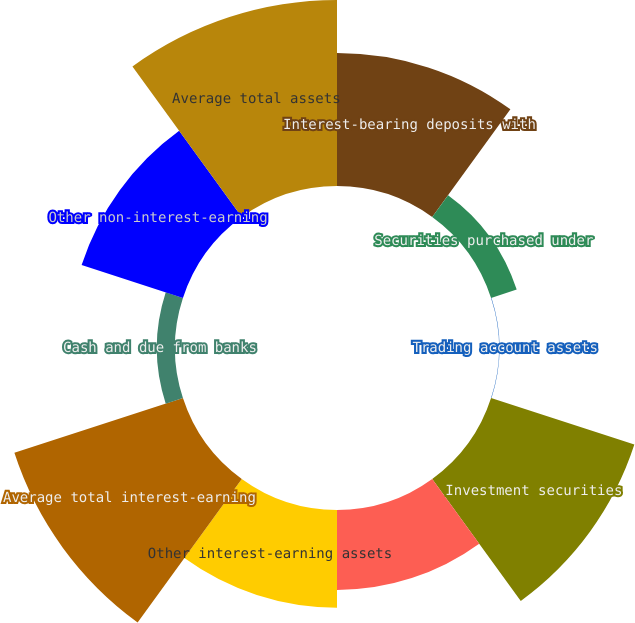Convert chart. <chart><loc_0><loc_0><loc_500><loc_500><pie_chart><fcel>Interest-bearing deposits with<fcel>Securities purchased under<fcel>Trading account assets<fcel>Investment securities<fcel>Loans and leases<fcel>Other interest-earning assets<fcel>Average total interest-earning<fcel>Cash and due from banks<fcel>Other non-interest-earning<fcel>Average total assets<nl><fcel>13.62%<fcel>2.76%<fcel>0.04%<fcel>15.43%<fcel>8.19%<fcel>10.0%<fcel>18.15%<fcel>1.85%<fcel>10.91%<fcel>19.05%<nl></chart> 